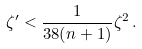<formula> <loc_0><loc_0><loc_500><loc_500>\zeta ^ { \prime } < \frac { 1 } { 3 8 ( n + 1 ) } \zeta ^ { 2 } \, .</formula> 